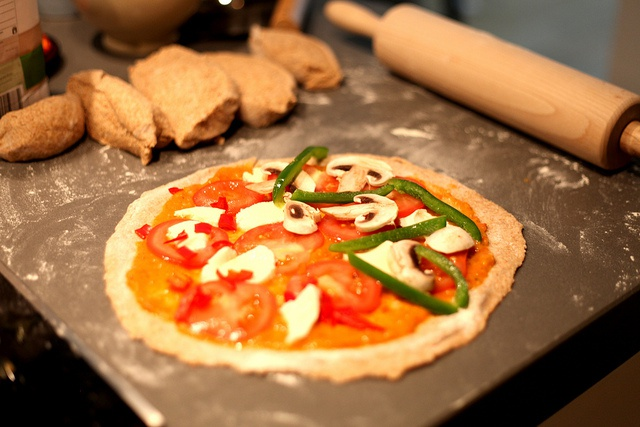Describe the objects in this image and their specific colors. I can see a pizza in brown, khaki, red, and orange tones in this image. 